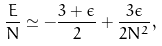Convert formula to latex. <formula><loc_0><loc_0><loc_500><loc_500>\frac { E } { N } \simeq - \frac { 3 + \epsilon } { 2 } + \frac { 3 \epsilon } { 2 N ^ { 2 } } ,</formula> 